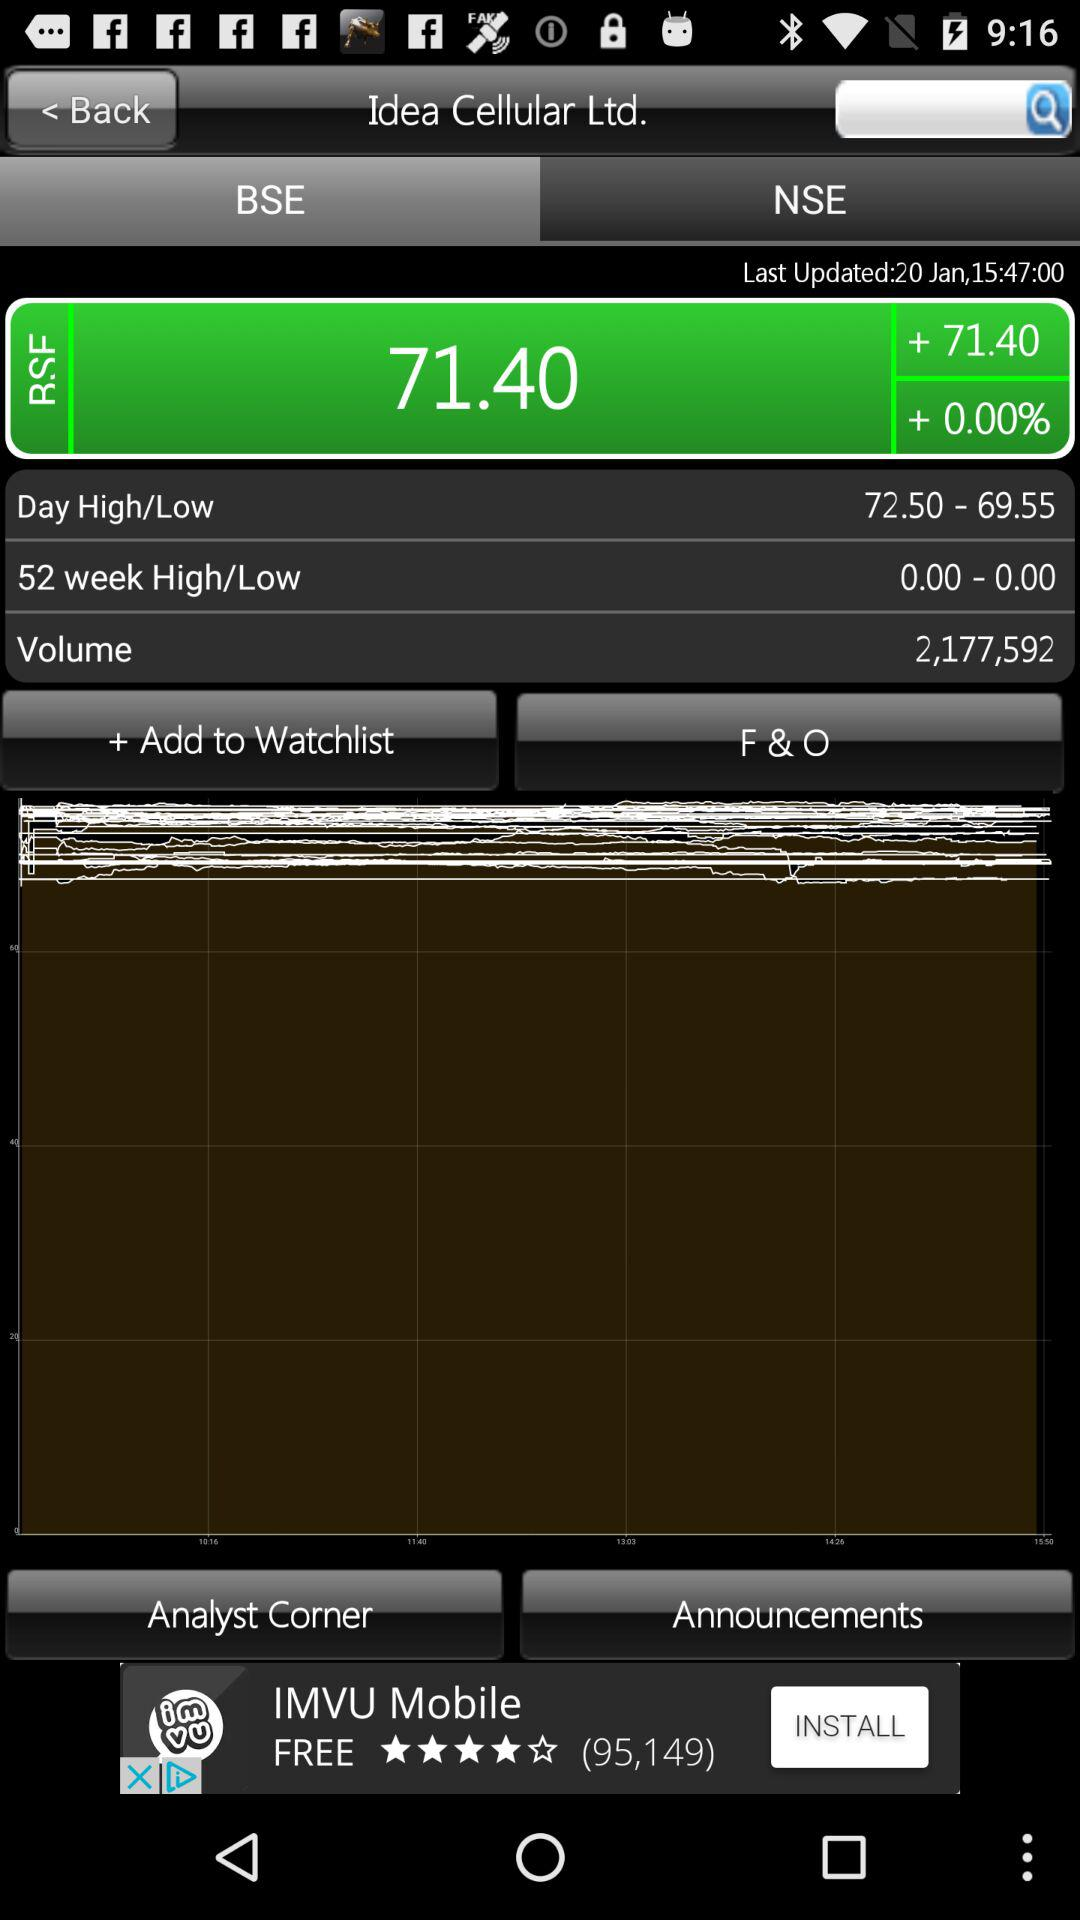What is the difference between the highest and lowest price of the stock today?
Answer the question using a single word or phrase. 2.95 